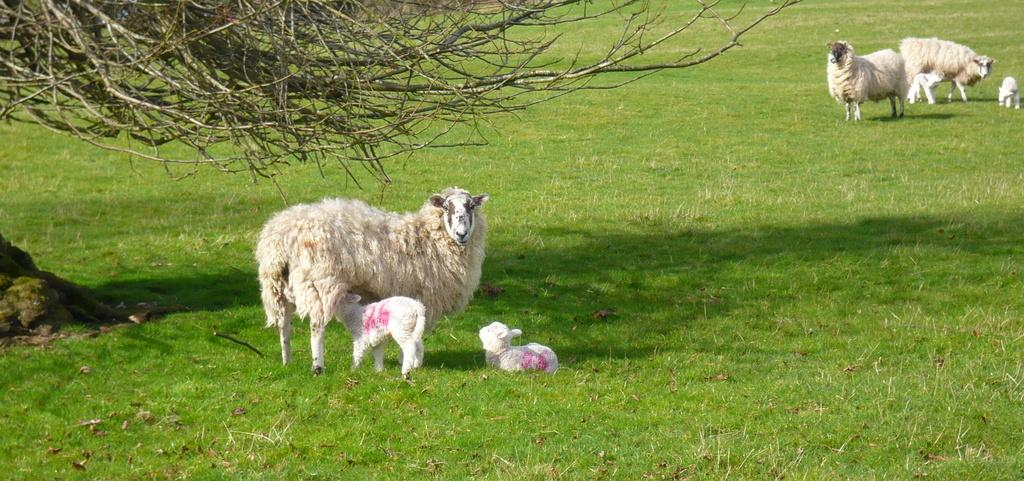What type of environment is shown in the image? The image is an outside view. What is covering the ground in the image? There is grass on the ground in the image. What other living beings can be seen in the image? There are animals visible in the image. What part of a plant can be seen at the top of the image? A part of a tree is visible at the top of the image. How many cents are scattered on the grass in the image? There are no cents visible in the image; it only shows grass and animals. 